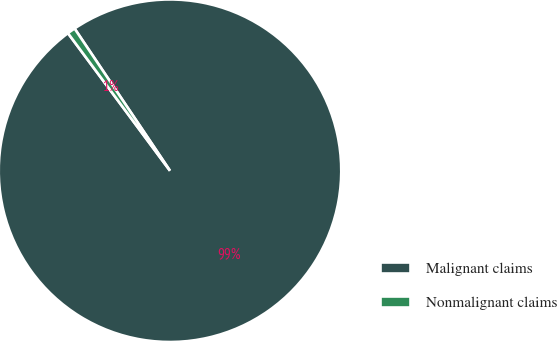<chart> <loc_0><loc_0><loc_500><loc_500><pie_chart><fcel>Malignant claims<fcel>Nonmalignant claims<nl><fcel>99.25%<fcel>0.75%<nl></chart> 